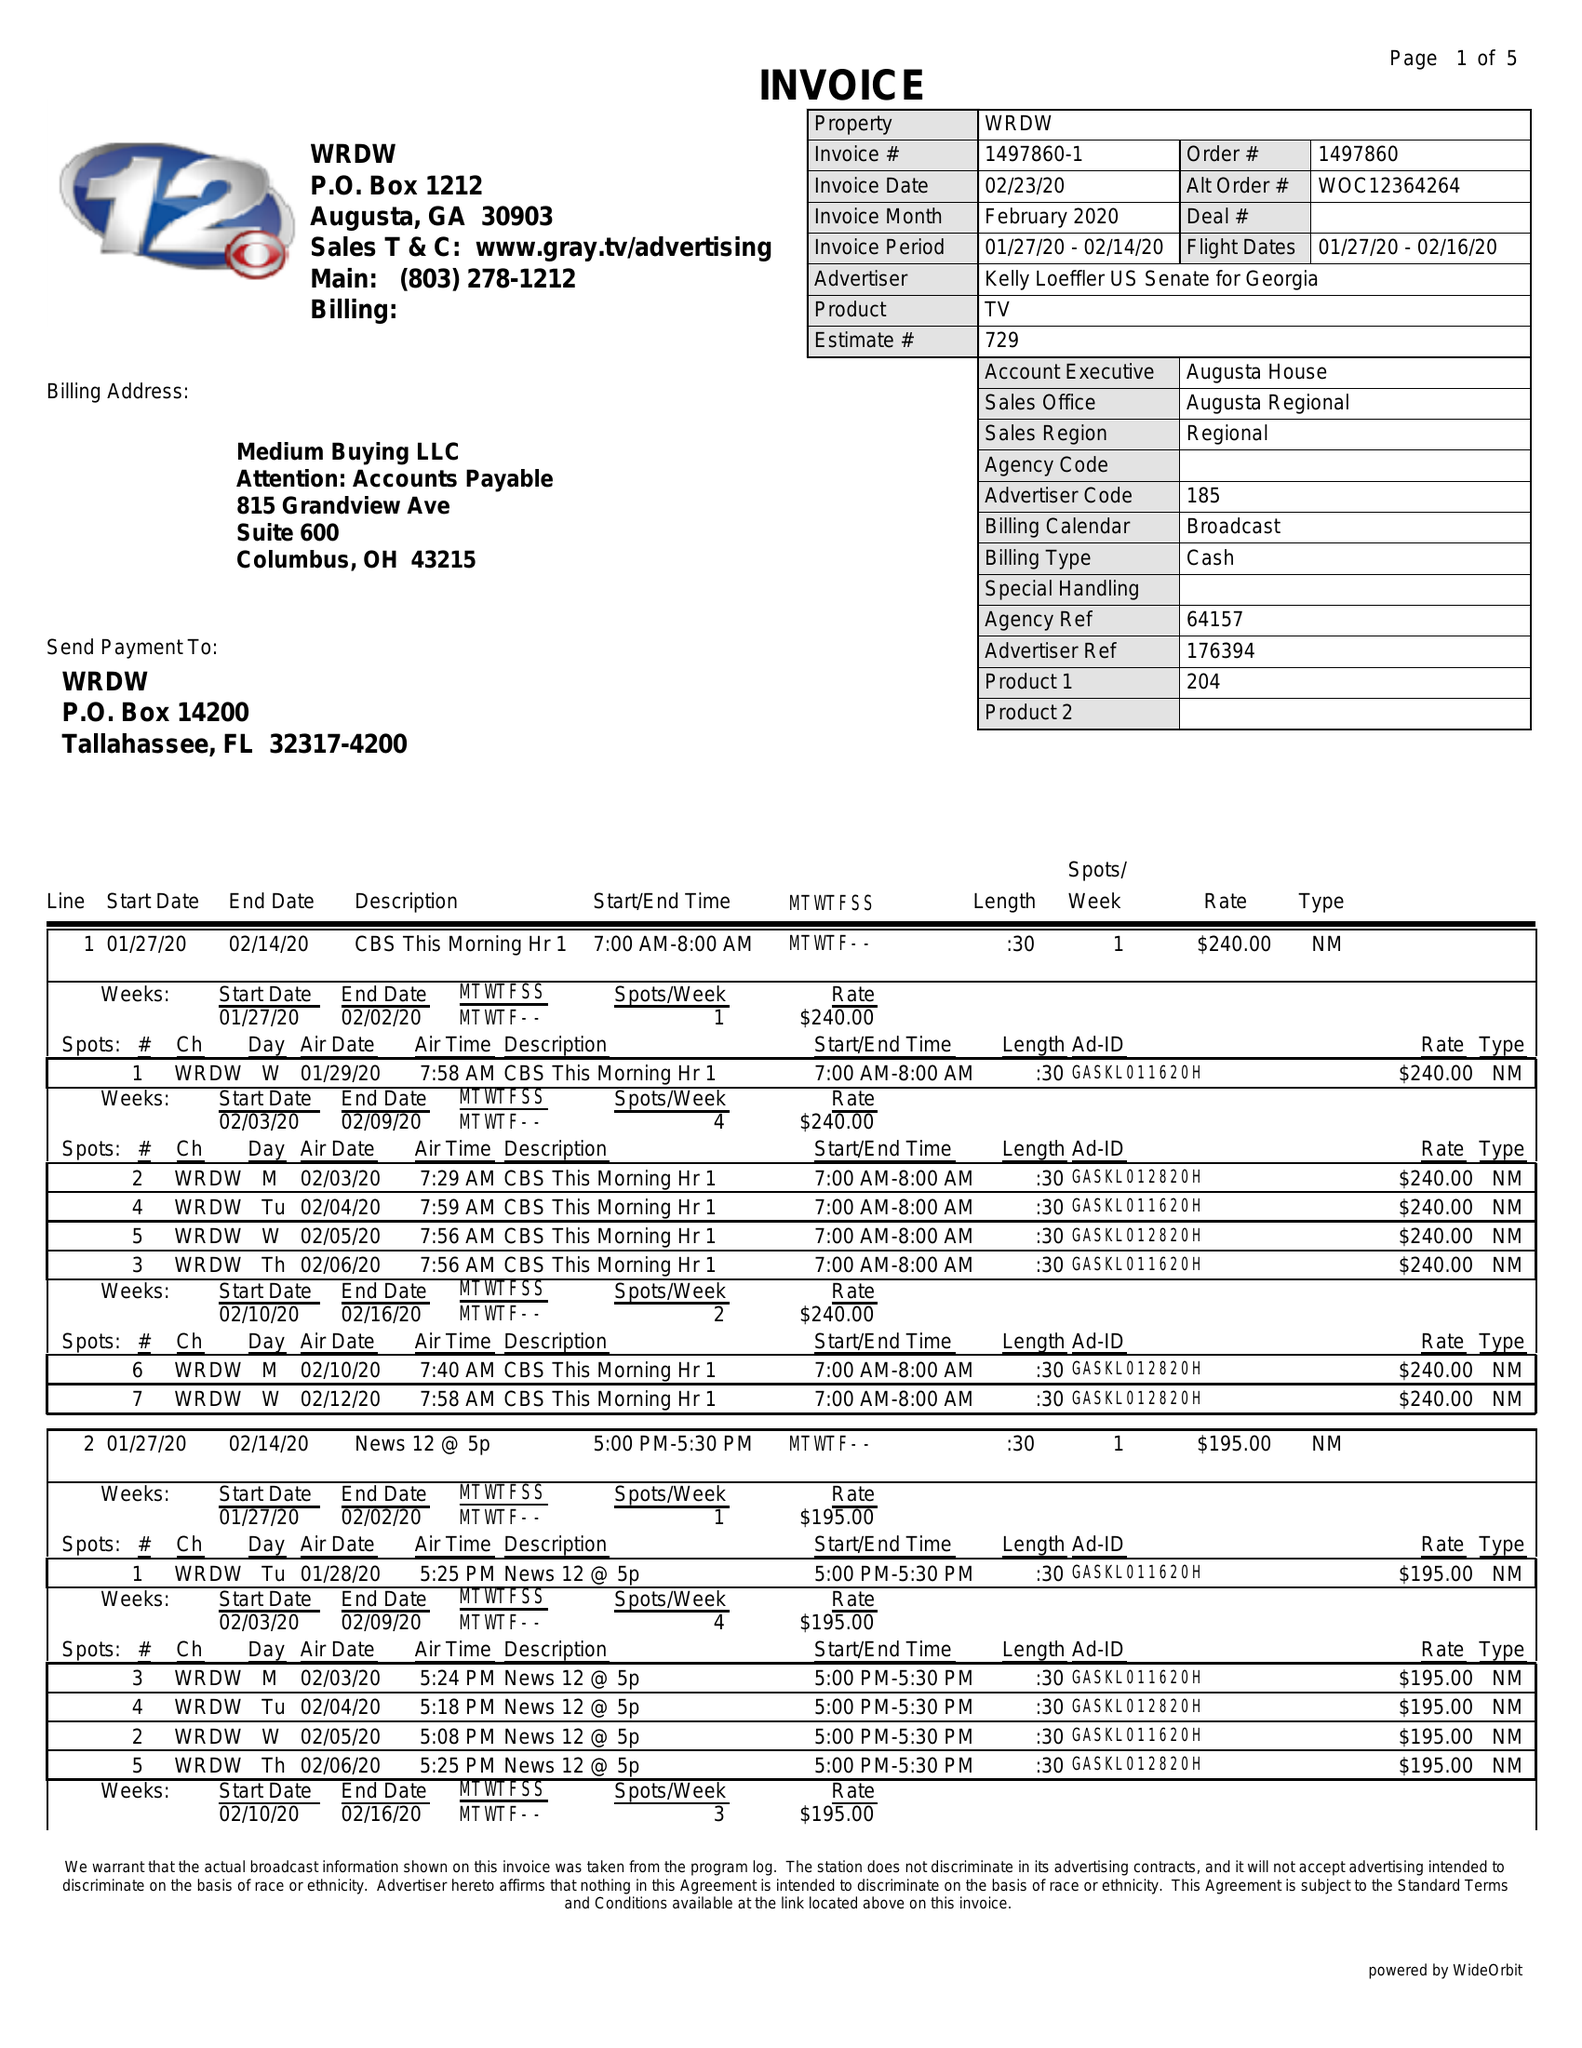What is the value for the contract_num?
Answer the question using a single word or phrase. 1497860 